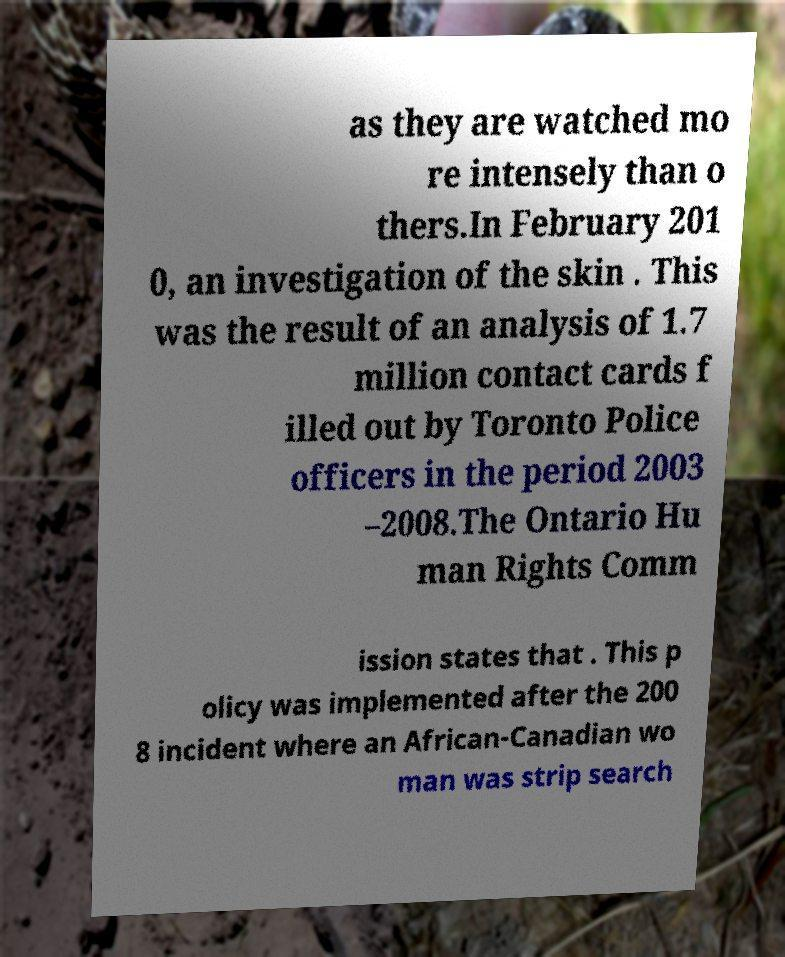Please read and relay the text visible in this image. What does it say? as they are watched mo re intensely than o thers.In February 201 0, an investigation of the skin . This was the result of an analysis of 1.7 million contact cards f illed out by Toronto Police officers in the period 2003 –2008.The Ontario Hu man Rights Comm ission states that . This p olicy was implemented after the 200 8 incident where an African-Canadian wo man was strip search 